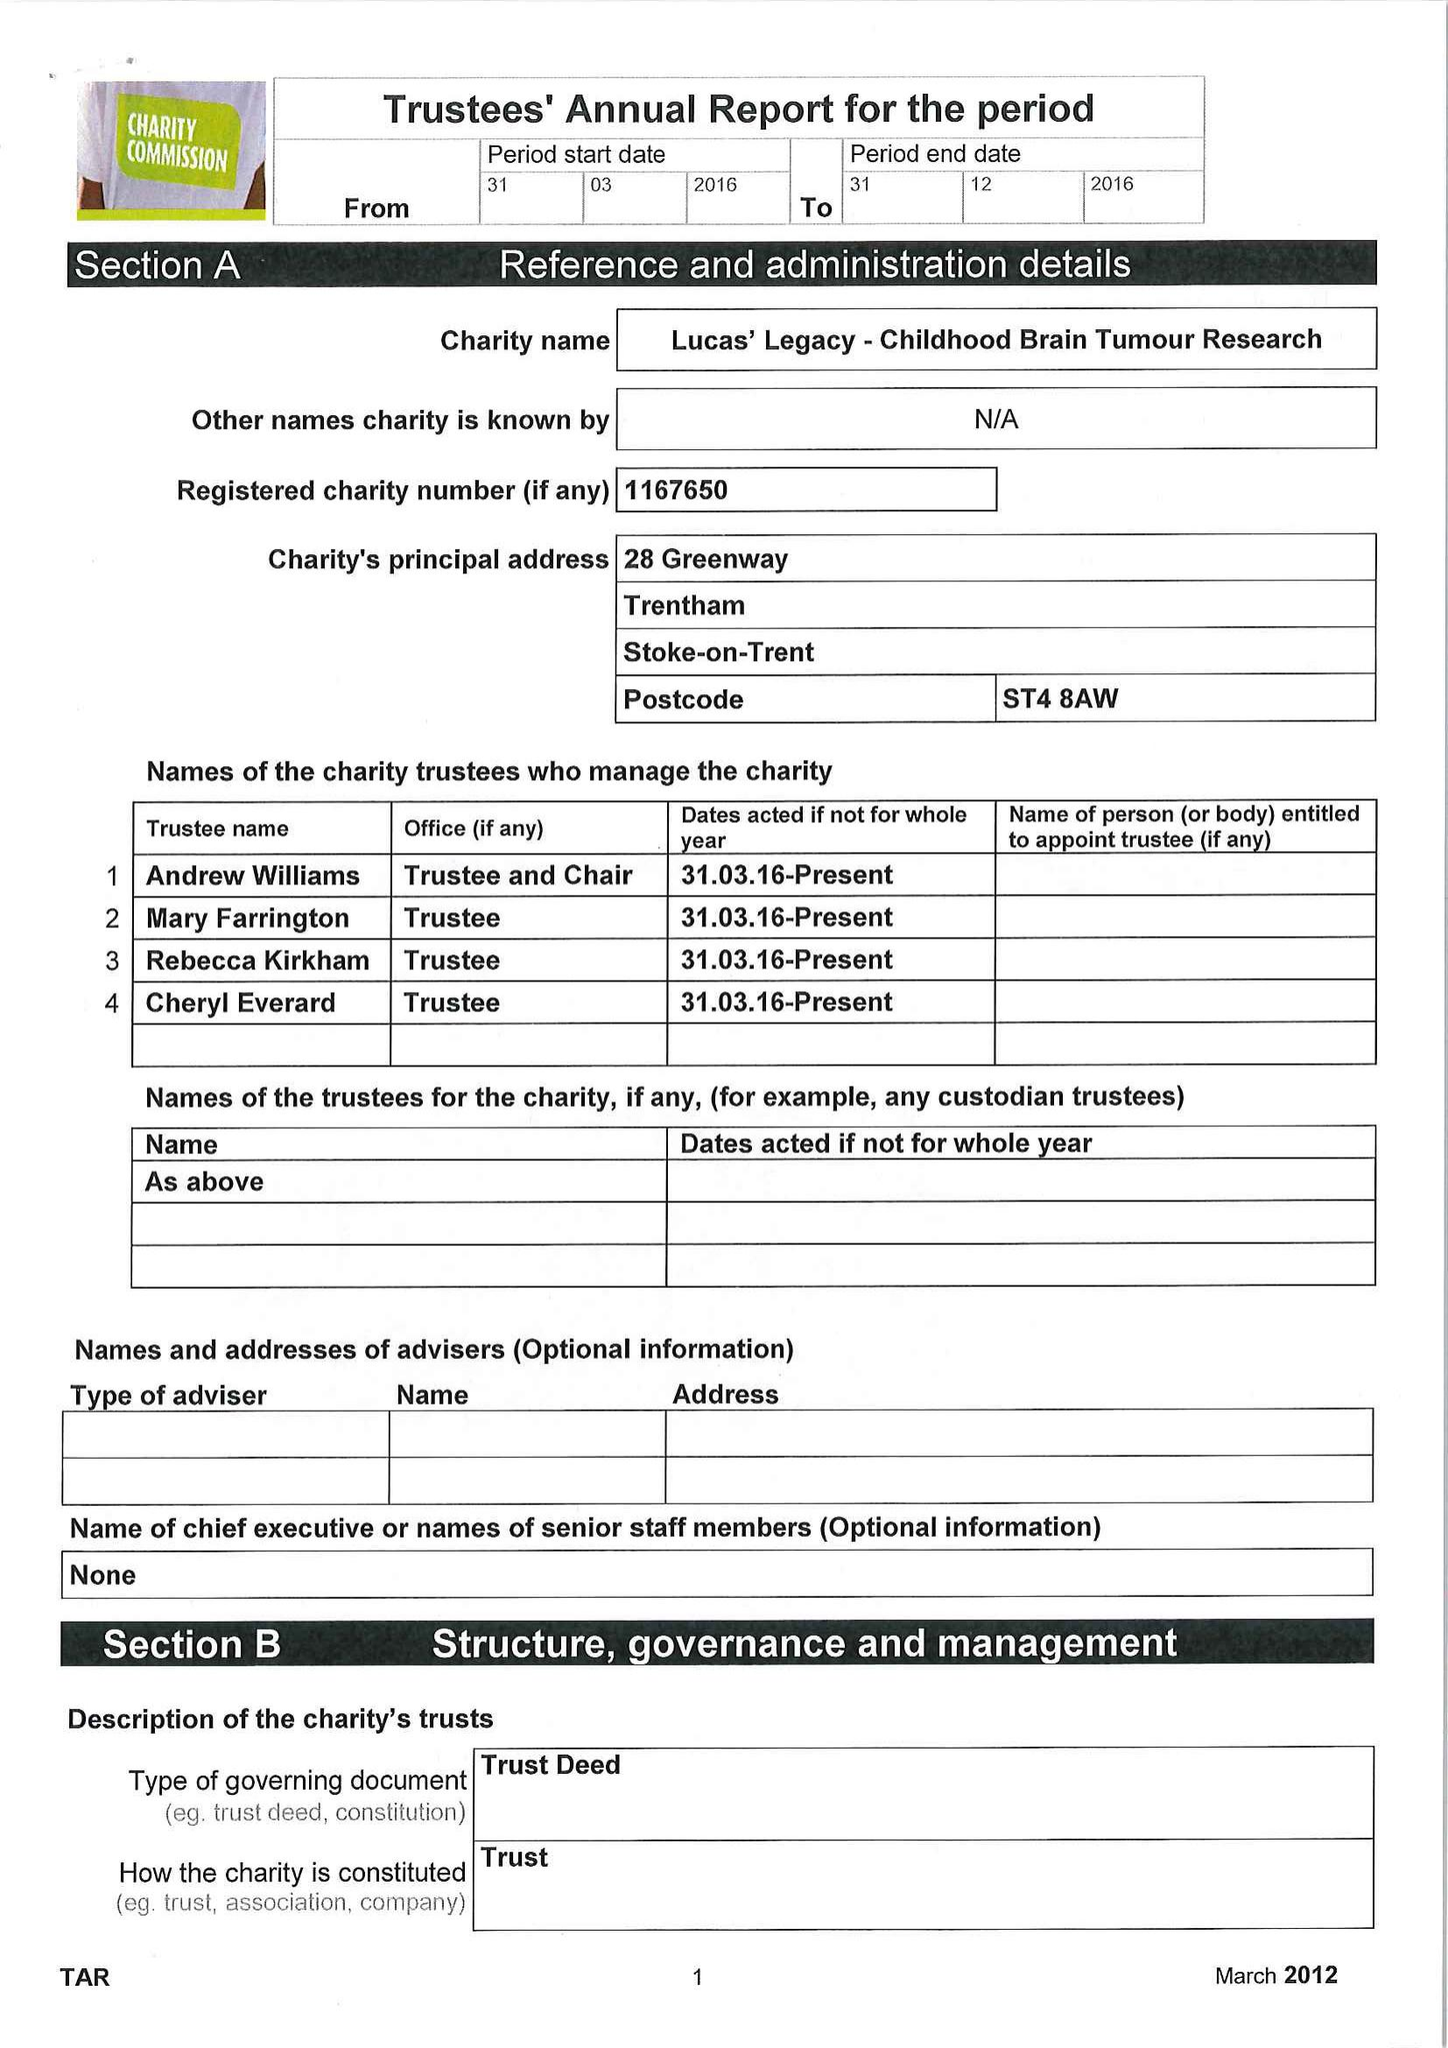What is the value for the spending_annually_in_british_pounds?
Answer the question using a single word or phrase. 932.00 